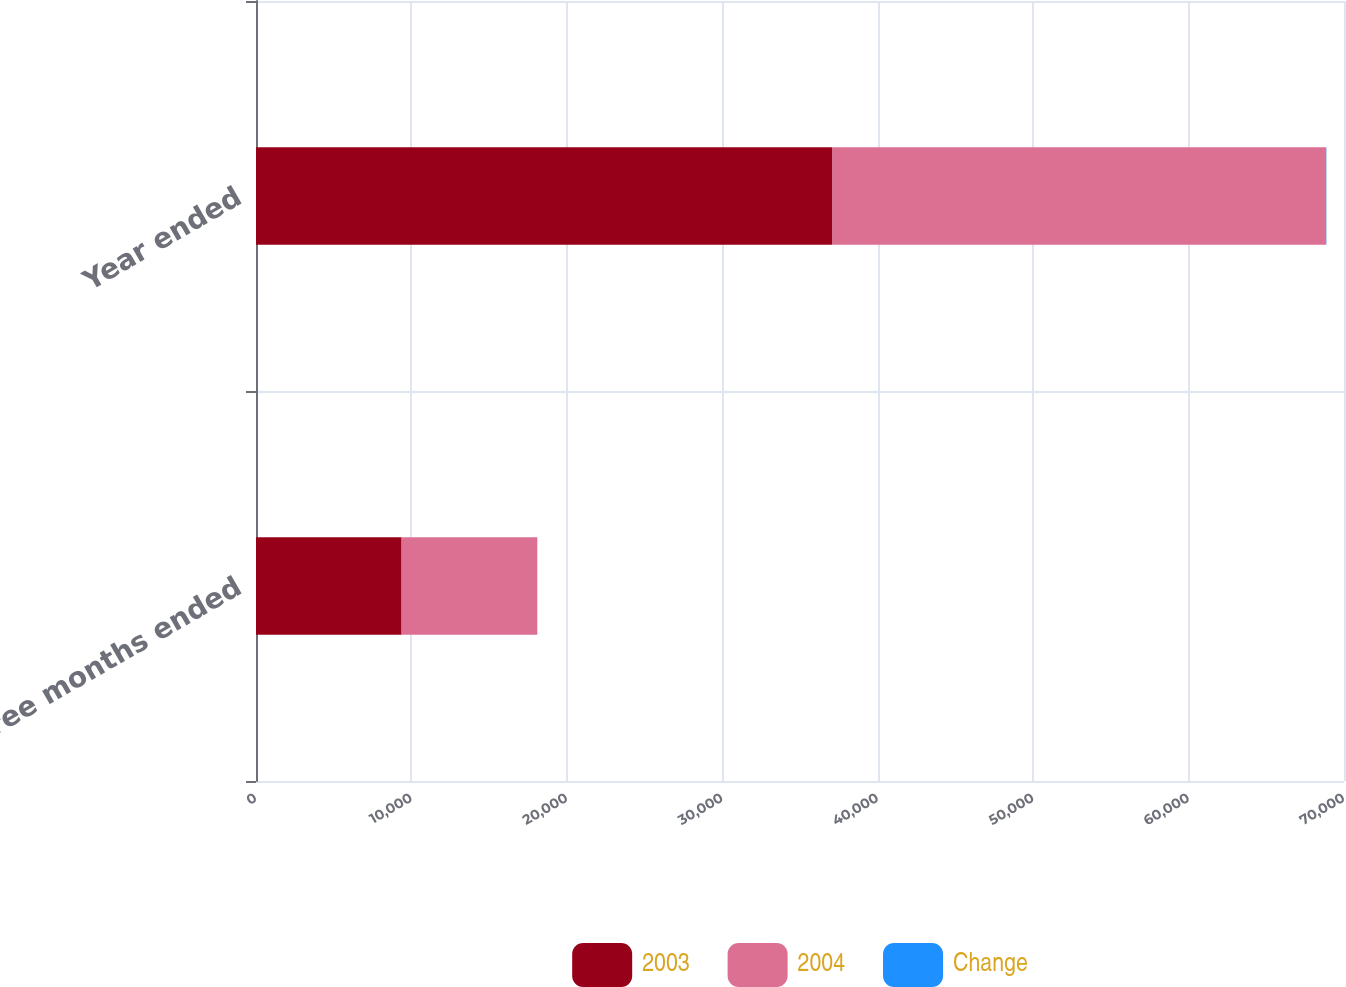Convert chart to OTSL. <chart><loc_0><loc_0><loc_500><loc_500><stacked_bar_chart><ecel><fcel>Three months ended<fcel>Year ended<nl><fcel>2003<fcel>9368<fcel>37093<nl><fcel>2004<fcel>8722<fcel>31759<nl><fcel>Change<fcel>7.4<fcel>16.8<nl></chart> 